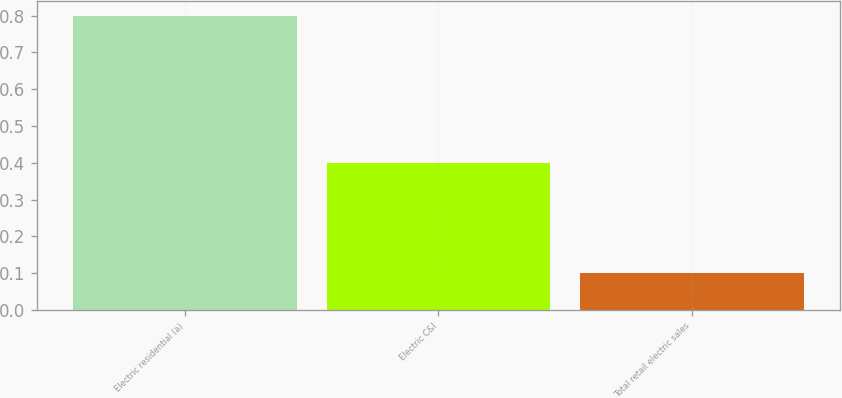Convert chart to OTSL. <chart><loc_0><loc_0><loc_500><loc_500><bar_chart><fcel>Electric residential (a)<fcel>Electric C&I<fcel>Total retail electric sales<nl><fcel>0.8<fcel>0.4<fcel>0.1<nl></chart> 